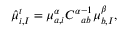Convert formula to latex. <formula><loc_0><loc_0><loc_500><loc_500>\begin{array} { r } { \hat { \mu } _ { i , I } ^ { t } = \mu _ { a , i } ^ { \alpha } { C ^ { \alpha } } _ { a b } ^ { - 1 } \mu _ { b , I } ^ { \beta } , } \end{array}</formula> 